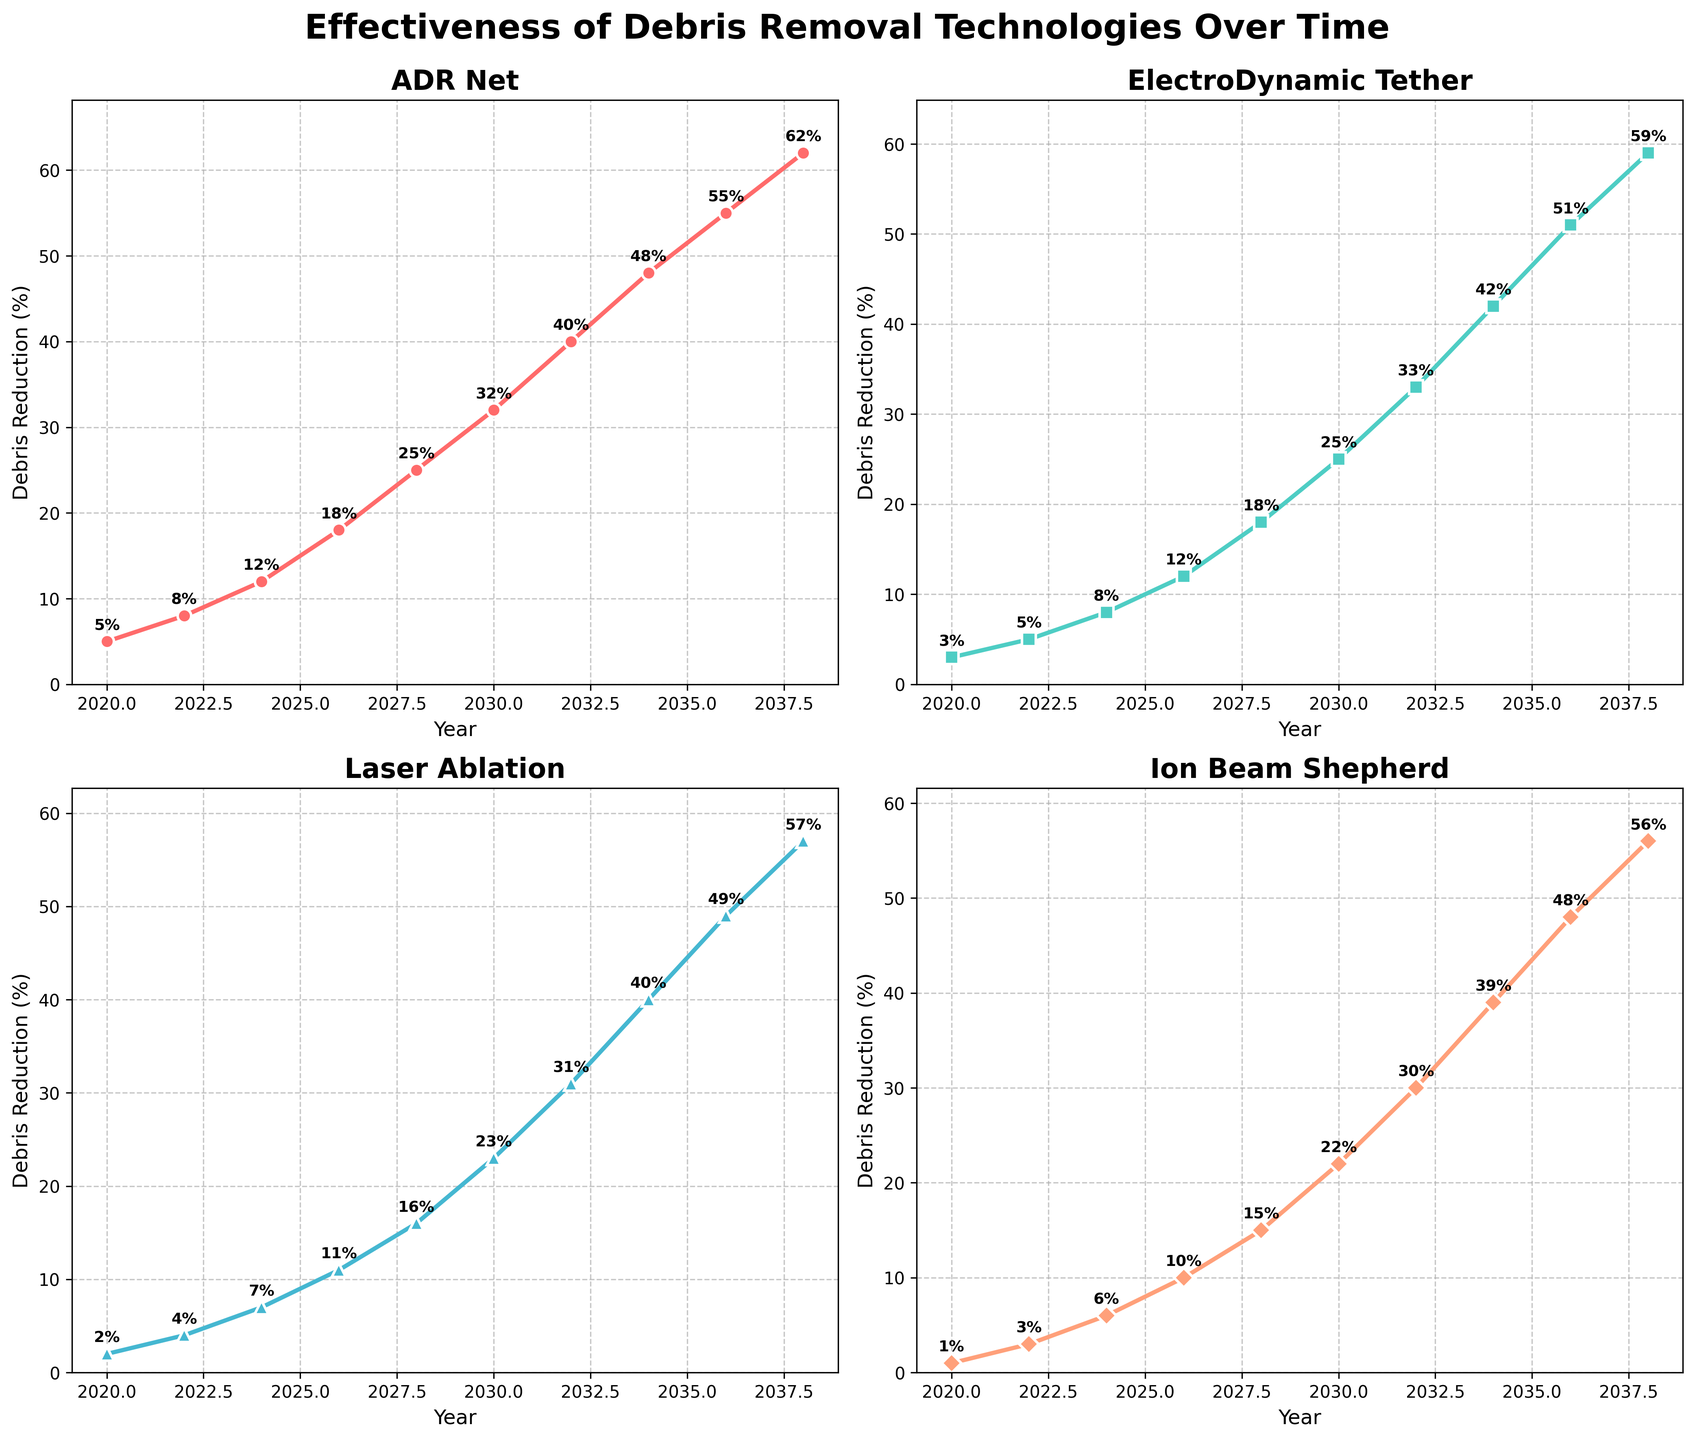What is the title of the entire figure? The title is located at the top of the figure and summarizes the main theme of the graphs.
Answer: Effectiveness of Debris Removal Technologies Over Time Which technology shows the highest debris reduction percentage in 2038? Look at the data points for each technology in the year 2038 and identify the one with the highest value.
Answer: ADR Net How many years are covered in the figure? Count the number of data points along the x-axis (years).
Answer: 10 years What is the approximate debris reduction percentage for Ion Beam Shepherd in 2022? Locate the Ion Beam Shepherd subplot and find the corresponding value for the year 2022.
Answer: 3% Which technology has the fastest growth in debris reduction from 2020 to 2038? Compare the slopes of each line; the steeper the line, the faster the growth.
Answer: ADR Net Which year does Laser Ablation first exceed 10% in debris reduction? Identify the year in the Laser Ablation subplot where the value crosses 10%.
Answer: 2026 For the year 2030, which technology has the smallest debris reduction percentage? Review the plots for each technology and compare the values for the year 2030.
Answer: Ion Beam Shepherd What is the average debris reduction percentage for ElectroDynamic Tether from 2020 to 2038? Sum the values of ElectroDynamic Tether for all years and divide by the number of data points.
Answer: (3+5+8+12+18+25+33+42+51+59)/10 = 25.6% By how much does the debris reduction percentage for ADR Net increase from 2022 to 2034? Subtract the value for 2022 from the value for 2034 for the ADR Net subplot.
Answer: 48% - 8% = 40% What is the slope of the line for the Laser Ablation from 2026 to 2028? Calculate the difference in debris reduction percentage between 2026 and 2028 for Laser Ablation and divide by the difference in years.
Answer: (16% - 11%) / (2028 - 2026) = 2.5% per year 